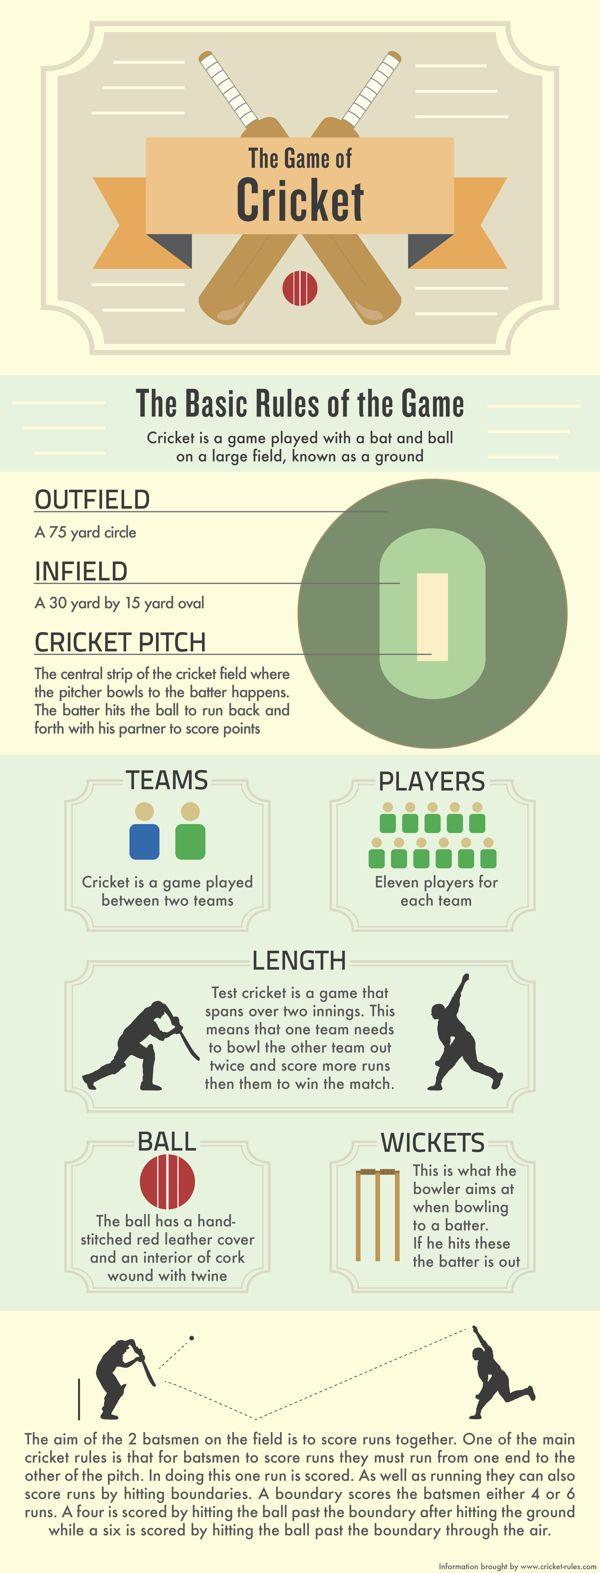List a handful of essential elements in this visual. There are four bats depicted in this infographic. The infographic contains two red balls. 